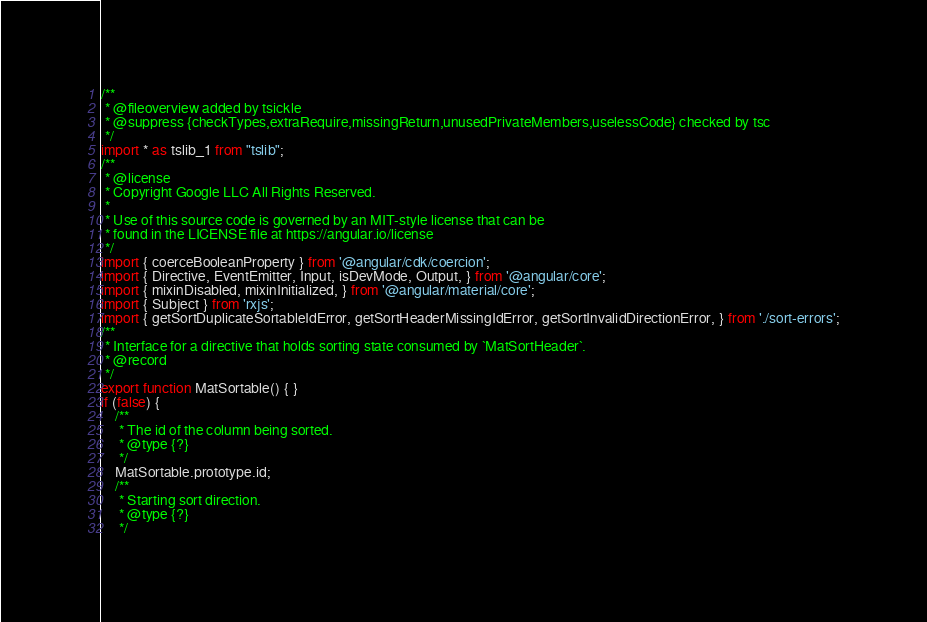Convert code to text. <code><loc_0><loc_0><loc_500><loc_500><_JavaScript_>/**
 * @fileoverview added by tsickle
 * @suppress {checkTypes,extraRequire,missingReturn,unusedPrivateMembers,uselessCode} checked by tsc
 */
import * as tslib_1 from "tslib";
/**
 * @license
 * Copyright Google LLC All Rights Reserved.
 *
 * Use of this source code is governed by an MIT-style license that can be
 * found in the LICENSE file at https://angular.io/license
 */
import { coerceBooleanProperty } from '@angular/cdk/coercion';
import { Directive, EventEmitter, Input, isDevMode, Output, } from '@angular/core';
import { mixinDisabled, mixinInitialized, } from '@angular/material/core';
import { Subject } from 'rxjs';
import { getSortDuplicateSortableIdError, getSortHeaderMissingIdError, getSortInvalidDirectionError, } from './sort-errors';
/**
 * Interface for a directive that holds sorting state consumed by `MatSortHeader`.
 * @record
 */
export function MatSortable() { }
if (false) {
    /**
     * The id of the column being sorted.
     * @type {?}
     */
    MatSortable.prototype.id;
    /**
     * Starting sort direction.
     * @type {?}
     */</code> 